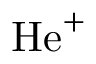Convert formula to latex. <formula><loc_0><loc_0><loc_500><loc_500>H e ^ { + }</formula> 